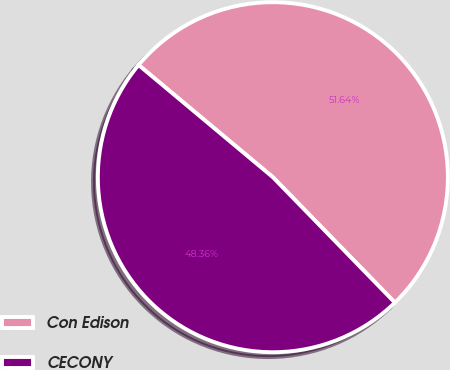Convert chart to OTSL. <chart><loc_0><loc_0><loc_500><loc_500><pie_chart><fcel>Con Edison<fcel>CECONY<nl><fcel>51.64%<fcel>48.36%<nl></chart> 